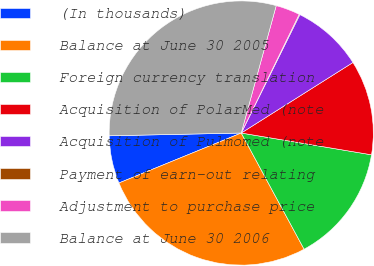<chart> <loc_0><loc_0><loc_500><loc_500><pie_chart><fcel>(In thousands)<fcel>Balance at June 30 2005<fcel>Foreign currency translation<fcel>Acquisition of PolarMed (note<fcel>Acquisition of Pulmomed (note<fcel>Payment of earn-out relating<fcel>Adjustment to purchase price<fcel>Balance at June 30 2006<nl><fcel>5.84%<fcel>26.72%<fcel>14.47%<fcel>11.6%<fcel>8.72%<fcel>0.09%<fcel>2.96%<fcel>29.6%<nl></chart> 